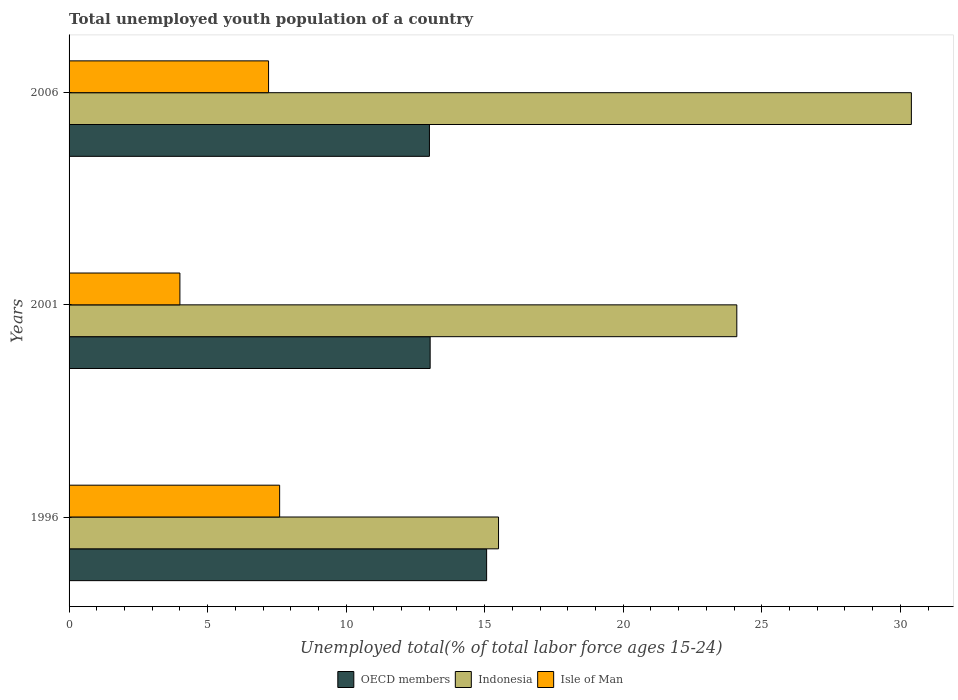Are the number of bars per tick equal to the number of legend labels?
Make the answer very short. Yes. Are the number of bars on each tick of the Y-axis equal?
Your answer should be compact. Yes. How many bars are there on the 2nd tick from the bottom?
Offer a terse response. 3. What is the percentage of total unemployed youth population of a country in Indonesia in 2001?
Offer a very short reply. 24.1. Across all years, what is the maximum percentage of total unemployed youth population of a country in OECD members?
Your answer should be compact. 15.07. In which year was the percentage of total unemployed youth population of a country in Indonesia maximum?
Your answer should be very brief. 2006. In which year was the percentage of total unemployed youth population of a country in OECD members minimum?
Offer a terse response. 2006. What is the total percentage of total unemployed youth population of a country in Isle of Man in the graph?
Offer a very short reply. 18.8. What is the difference between the percentage of total unemployed youth population of a country in OECD members in 1996 and that in 2001?
Your answer should be very brief. 2.04. What is the difference between the percentage of total unemployed youth population of a country in Isle of Man in 2006 and the percentage of total unemployed youth population of a country in OECD members in 2001?
Ensure brevity in your answer.  -5.83. What is the average percentage of total unemployed youth population of a country in OECD members per year?
Ensure brevity in your answer.  13.7. In the year 2006, what is the difference between the percentage of total unemployed youth population of a country in Indonesia and percentage of total unemployed youth population of a country in Isle of Man?
Your response must be concise. 23.2. In how many years, is the percentage of total unemployed youth population of a country in OECD members greater than 26 %?
Offer a very short reply. 0. What is the ratio of the percentage of total unemployed youth population of a country in Indonesia in 2001 to that in 2006?
Give a very brief answer. 0.79. Is the difference between the percentage of total unemployed youth population of a country in Indonesia in 1996 and 2001 greater than the difference between the percentage of total unemployed youth population of a country in Isle of Man in 1996 and 2001?
Provide a short and direct response. No. What is the difference between the highest and the second highest percentage of total unemployed youth population of a country in OECD members?
Your response must be concise. 2.04. What is the difference between the highest and the lowest percentage of total unemployed youth population of a country in Indonesia?
Make the answer very short. 14.9. What does the 3rd bar from the top in 2006 represents?
Keep it short and to the point. OECD members. What does the 2nd bar from the bottom in 2006 represents?
Provide a short and direct response. Indonesia. Are all the bars in the graph horizontal?
Provide a succinct answer. Yes. How many years are there in the graph?
Keep it short and to the point. 3. What is the difference between two consecutive major ticks on the X-axis?
Your answer should be very brief. 5. Are the values on the major ticks of X-axis written in scientific E-notation?
Offer a very short reply. No. How many legend labels are there?
Make the answer very short. 3. How are the legend labels stacked?
Give a very brief answer. Horizontal. What is the title of the graph?
Your response must be concise. Total unemployed youth population of a country. What is the label or title of the X-axis?
Your answer should be very brief. Unemployed total(% of total labor force ages 15-24). What is the label or title of the Y-axis?
Provide a succinct answer. Years. What is the Unemployed total(% of total labor force ages 15-24) in OECD members in 1996?
Give a very brief answer. 15.07. What is the Unemployed total(% of total labor force ages 15-24) in Indonesia in 1996?
Your answer should be very brief. 15.5. What is the Unemployed total(% of total labor force ages 15-24) in Isle of Man in 1996?
Your answer should be very brief. 7.6. What is the Unemployed total(% of total labor force ages 15-24) of OECD members in 2001?
Give a very brief answer. 13.03. What is the Unemployed total(% of total labor force ages 15-24) in Indonesia in 2001?
Your answer should be compact. 24.1. What is the Unemployed total(% of total labor force ages 15-24) in Isle of Man in 2001?
Your answer should be very brief. 4. What is the Unemployed total(% of total labor force ages 15-24) in OECD members in 2006?
Your answer should be compact. 13.01. What is the Unemployed total(% of total labor force ages 15-24) of Indonesia in 2006?
Your answer should be compact. 30.4. What is the Unemployed total(% of total labor force ages 15-24) of Isle of Man in 2006?
Offer a very short reply. 7.2. Across all years, what is the maximum Unemployed total(% of total labor force ages 15-24) of OECD members?
Provide a succinct answer. 15.07. Across all years, what is the maximum Unemployed total(% of total labor force ages 15-24) of Indonesia?
Ensure brevity in your answer.  30.4. Across all years, what is the maximum Unemployed total(% of total labor force ages 15-24) in Isle of Man?
Keep it short and to the point. 7.6. Across all years, what is the minimum Unemployed total(% of total labor force ages 15-24) of OECD members?
Keep it short and to the point. 13.01. Across all years, what is the minimum Unemployed total(% of total labor force ages 15-24) of Indonesia?
Provide a short and direct response. 15.5. What is the total Unemployed total(% of total labor force ages 15-24) in OECD members in the graph?
Your answer should be compact. 41.11. What is the total Unemployed total(% of total labor force ages 15-24) in Indonesia in the graph?
Provide a succinct answer. 70. What is the total Unemployed total(% of total labor force ages 15-24) of Isle of Man in the graph?
Offer a very short reply. 18.8. What is the difference between the Unemployed total(% of total labor force ages 15-24) in OECD members in 1996 and that in 2001?
Offer a terse response. 2.04. What is the difference between the Unemployed total(% of total labor force ages 15-24) of OECD members in 1996 and that in 2006?
Provide a succinct answer. 2.06. What is the difference between the Unemployed total(% of total labor force ages 15-24) in Indonesia in 1996 and that in 2006?
Your response must be concise. -14.9. What is the difference between the Unemployed total(% of total labor force ages 15-24) in Isle of Man in 1996 and that in 2006?
Ensure brevity in your answer.  0.4. What is the difference between the Unemployed total(% of total labor force ages 15-24) in OECD members in 2001 and that in 2006?
Provide a succinct answer. 0.03. What is the difference between the Unemployed total(% of total labor force ages 15-24) of Isle of Man in 2001 and that in 2006?
Offer a very short reply. -3.2. What is the difference between the Unemployed total(% of total labor force ages 15-24) in OECD members in 1996 and the Unemployed total(% of total labor force ages 15-24) in Indonesia in 2001?
Your answer should be compact. -9.03. What is the difference between the Unemployed total(% of total labor force ages 15-24) in OECD members in 1996 and the Unemployed total(% of total labor force ages 15-24) in Isle of Man in 2001?
Provide a short and direct response. 11.07. What is the difference between the Unemployed total(% of total labor force ages 15-24) in Indonesia in 1996 and the Unemployed total(% of total labor force ages 15-24) in Isle of Man in 2001?
Offer a terse response. 11.5. What is the difference between the Unemployed total(% of total labor force ages 15-24) in OECD members in 1996 and the Unemployed total(% of total labor force ages 15-24) in Indonesia in 2006?
Ensure brevity in your answer.  -15.33. What is the difference between the Unemployed total(% of total labor force ages 15-24) in OECD members in 1996 and the Unemployed total(% of total labor force ages 15-24) in Isle of Man in 2006?
Keep it short and to the point. 7.87. What is the difference between the Unemployed total(% of total labor force ages 15-24) of OECD members in 2001 and the Unemployed total(% of total labor force ages 15-24) of Indonesia in 2006?
Offer a very short reply. -17.37. What is the difference between the Unemployed total(% of total labor force ages 15-24) of OECD members in 2001 and the Unemployed total(% of total labor force ages 15-24) of Isle of Man in 2006?
Make the answer very short. 5.83. What is the difference between the Unemployed total(% of total labor force ages 15-24) in Indonesia in 2001 and the Unemployed total(% of total labor force ages 15-24) in Isle of Man in 2006?
Provide a succinct answer. 16.9. What is the average Unemployed total(% of total labor force ages 15-24) of OECD members per year?
Give a very brief answer. 13.7. What is the average Unemployed total(% of total labor force ages 15-24) of Indonesia per year?
Your answer should be compact. 23.33. What is the average Unemployed total(% of total labor force ages 15-24) in Isle of Man per year?
Provide a short and direct response. 6.27. In the year 1996, what is the difference between the Unemployed total(% of total labor force ages 15-24) in OECD members and Unemployed total(% of total labor force ages 15-24) in Indonesia?
Provide a short and direct response. -0.43. In the year 1996, what is the difference between the Unemployed total(% of total labor force ages 15-24) of OECD members and Unemployed total(% of total labor force ages 15-24) of Isle of Man?
Offer a terse response. 7.47. In the year 1996, what is the difference between the Unemployed total(% of total labor force ages 15-24) of Indonesia and Unemployed total(% of total labor force ages 15-24) of Isle of Man?
Keep it short and to the point. 7.9. In the year 2001, what is the difference between the Unemployed total(% of total labor force ages 15-24) of OECD members and Unemployed total(% of total labor force ages 15-24) of Indonesia?
Provide a succinct answer. -11.07. In the year 2001, what is the difference between the Unemployed total(% of total labor force ages 15-24) of OECD members and Unemployed total(% of total labor force ages 15-24) of Isle of Man?
Offer a terse response. 9.03. In the year 2001, what is the difference between the Unemployed total(% of total labor force ages 15-24) of Indonesia and Unemployed total(% of total labor force ages 15-24) of Isle of Man?
Give a very brief answer. 20.1. In the year 2006, what is the difference between the Unemployed total(% of total labor force ages 15-24) of OECD members and Unemployed total(% of total labor force ages 15-24) of Indonesia?
Give a very brief answer. -17.39. In the year 2006, what is the difference between the Unemployed total(% of total labor force ages 15-24) of OECD members and Unemployed total(% of total labor force ages 15-24) of Isle of Man?
Your answer should be very brief. 5.81. In the year 2006, what is the difference between the Unemployed total(% of total labor force ages 15-24) of Indonesia and Unemployed total(% of total labor force ages 15-24) of Isle of Man?
Keep it short and to the point. 23.2. What is the ratio of the Unemployed total(% of total labor force ages 15-24) in OECD members in 1996 to that in 2001?
Provide a succinct answer. 1.16. What is the ratio of the Unemployed total(% of total labor force ages 15-24) in Indonesia in 1996 to that in 2001?
Provide a succinct answer. 0.64. What is the ratio of the Unemployed total(% of total labor force ages 15-24) of OECD members in 1996 to that in 2006?
Provide a short and direct response. 1.16. What is the ratio of the Unemployed total(% of total labor force ages 15-24) of Indonesia in 1996 to that in 2006?
Offer a very short reply. 0.51. What is the ratio of the Unemployed total(% of total labor force ages 15-24) of Isle of Man in 1996 to that in 2006?
Offer a terse response. 1.06. What is the ratio of the Unemployed total(% of total labor force ages 15-24) of OECD members in 2001 to that in 2006?
Provide a succinct answer. 1. What is the ratio of the Unemployed total(% of total labor force ages 15-24) of Indonesia in 2001 to that in 2006?
Offer a terse response. 0.79. What is the ratio of the Unemployed total(% of total labor force ages 15-24) in Isle of Man in 2001 to that in 2006?
Offer a terse response. 0.56. What is the difference between the highest and the second highest Unemployed total(% of total labor force ages 15-24) in OECD members?
Your response must be concise. 2.04. What is the difference between the highest and the second highest Unemployed total(% of total labor force ages 15-24) of Indonesia?
Provide a short and direct response. 6.3. What is the difference between the highest and the lowest Unemployed total(% of total labor force ages 15-24) in OECD members?
Provide a succinct answer. 2.06. What is the difference between the highest and the lowest Unemployed total(% of total labor force ages 15-24) in Indonesia?
Your answer should be very brief. 14.9. 